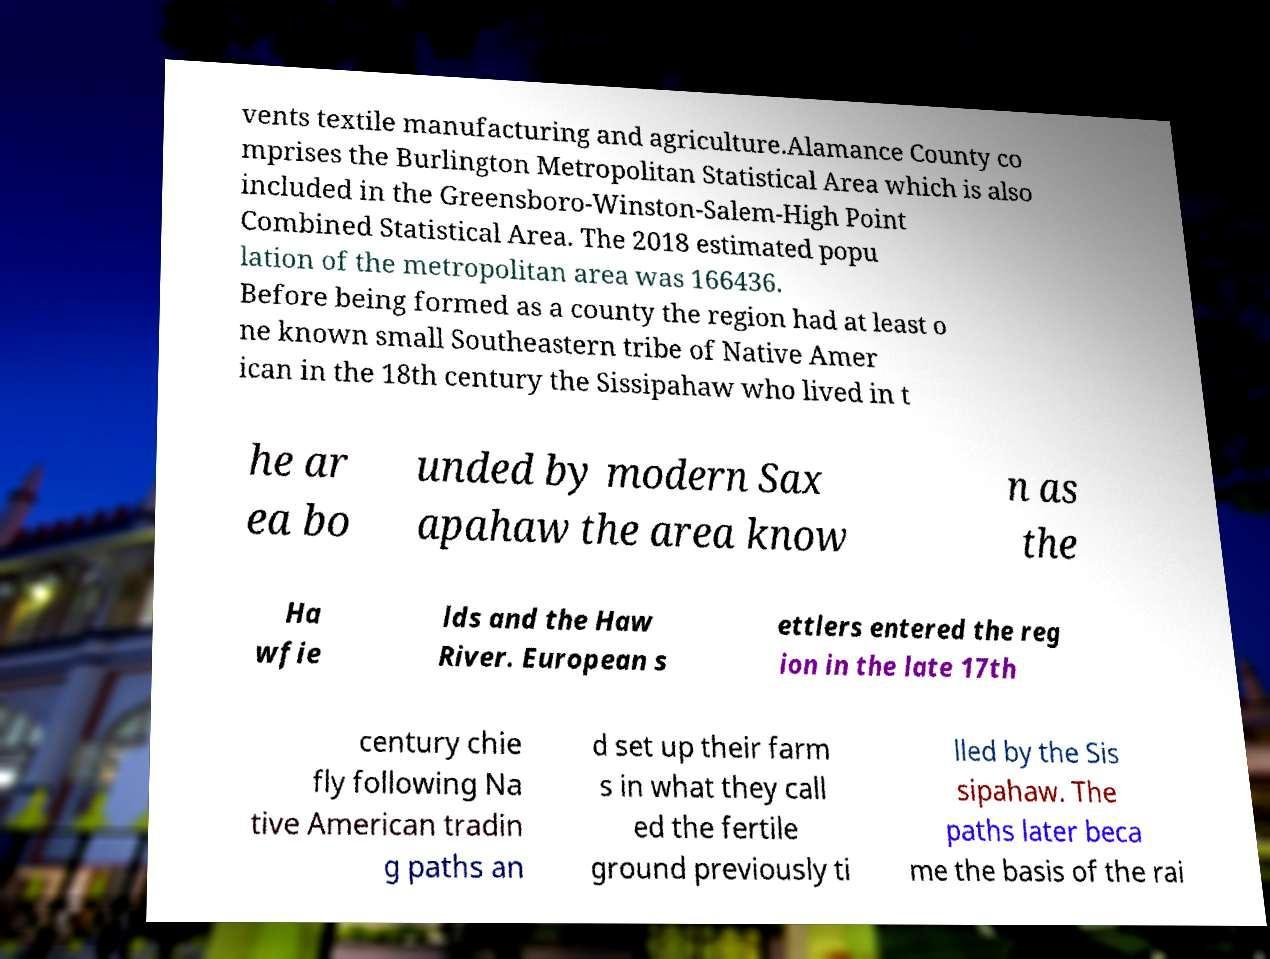Could you assist in decoding the text presented in this image and type it out clearly? vents textile manufacturing and agriculture.Alamance County co mprises the Burlington Metropolitan Statistical Area which is also included in the Greensboro-Winston-Salem-High Point Combined Statistical Area. The 2018 estimated popu lation of the metropolitan area was 166436. Before being formed as a county the region had at least o ne known small Southeastern tribe of Native Amer ican in the 18th century the Sissipahaw who lived in t he ar ea bo unded by modern Sax apahaw the area know n as the Ha wfie lds and the Haw River. European s ettlers entered the reg ion in the late 17th century chie fly following Na tive American tradin g paths an d set up their farm s in what they call ed the fertile ground previously ti lled by the Sis sipahaw. The paths later beca me the basis of the rai 